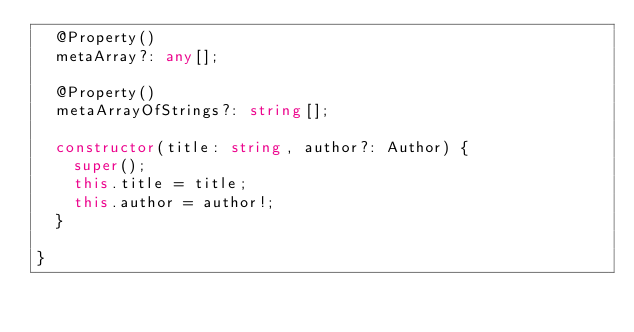<code> <loc_0><loc_0><loc_500><loc_500><_TypeScript_>  @Property()
  metaArray?: any[];

  @Property()
  metaArrayOfStrings?: string[];

  constructor(title: string, author?: Author) {
    super();
    this.title = title;
    this.author = author!;
  }

}
</code> 